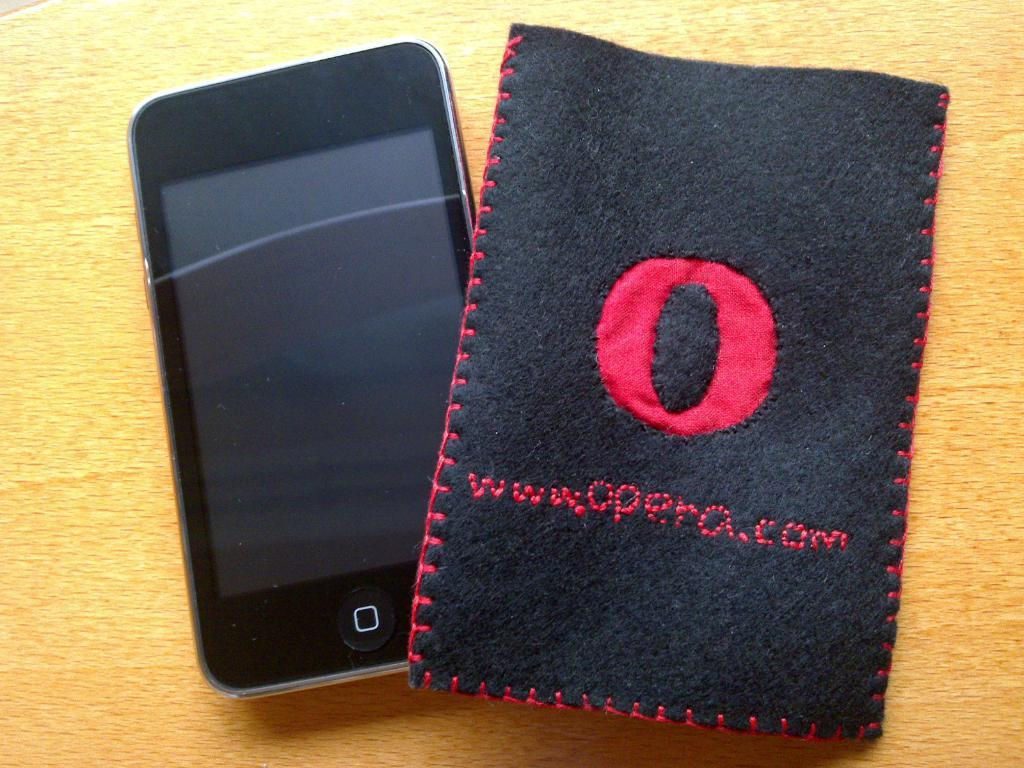<image>
Write a terse but informative summary of the picture. A small phone next to a cover with the website Opera.com sewn on it. 